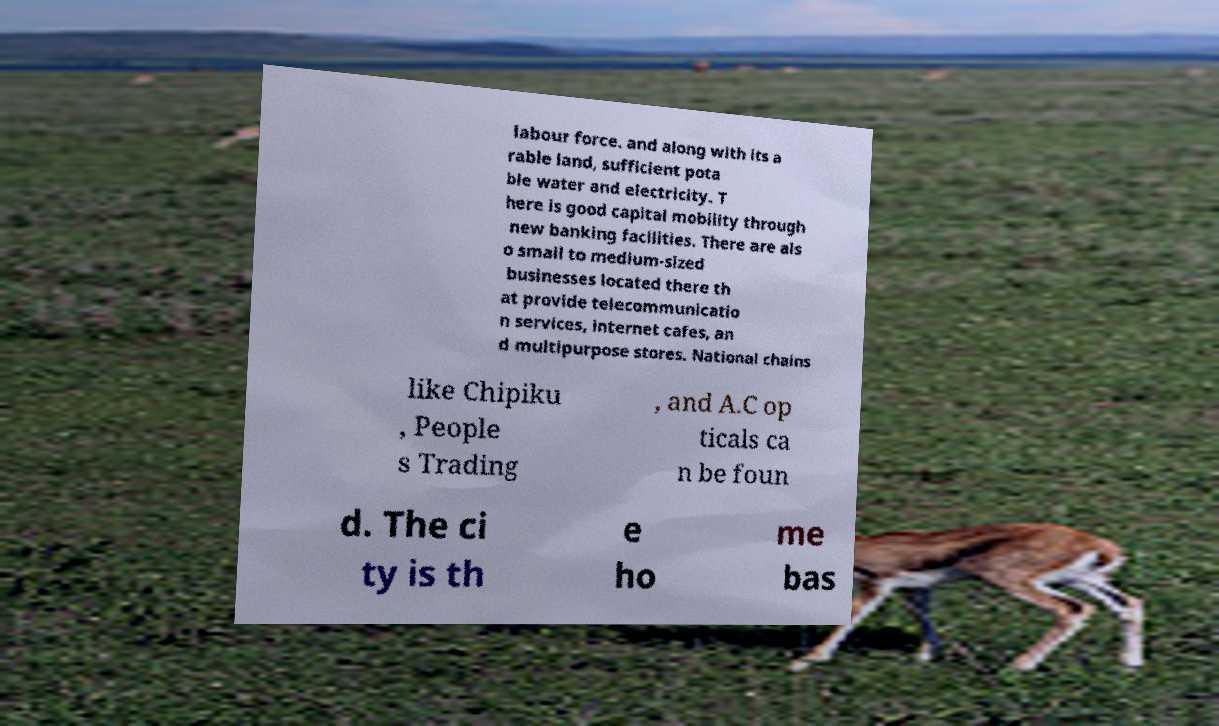What messages or text are displayed in this image? I need them in a readable, typed format. labour force. and along with its a rable land, sufficient pota ble water and electricity. T here is good capital mobility through new banking facilities. There are als o small to medium-sized businesses located there th at provide telecommunicatio n services, internet cafes, an d multipurpose stores. National chains like Chipiku , People s Trading , and A.C op ticals ca n be foun d. The ci ty is th e ho me bas 